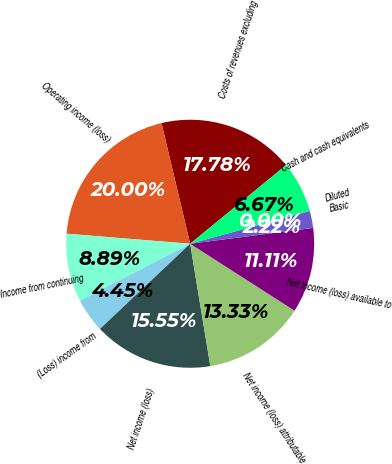Convert chart. <chart><loc_0><loc_0><loc_500><loc_500><pie_chart><fcel>Costs of revenues excluding<fcel>Operating income (loss)<fcel>Income from continuing<fcel>(Loss) income from<fcel>Net income (loss)<fcel>Net income (loss) attributable<fcel>Net income (loss) available to<fcel>Basic<fcel>Diluted<fcel>Cash and cash equivalents<nl><fcel>17.78%<fcel>20.0%<fcel>8.89%<fcel>4.45%<fcel>15.55%<fcel>13.33%<fcel>11.11%<fcel>2.22%<fcel>0.0%<fcel>6.67%<nl></chart> 